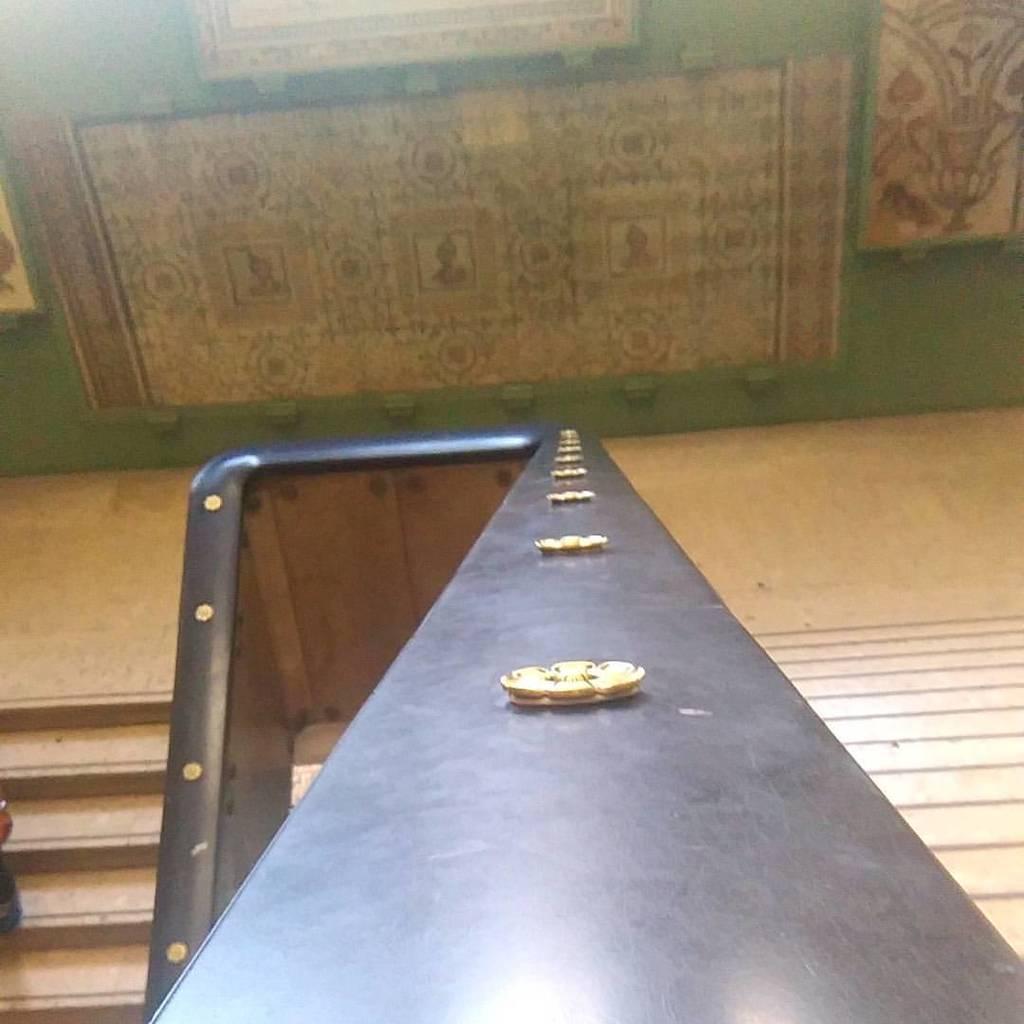Can you describe this image briefly? In this picture I can see the stairs. In the center I can see the railing. In the bottom left corner I can see the person's leg and hand. At the top I can see the carpet which is placed on the wall. 